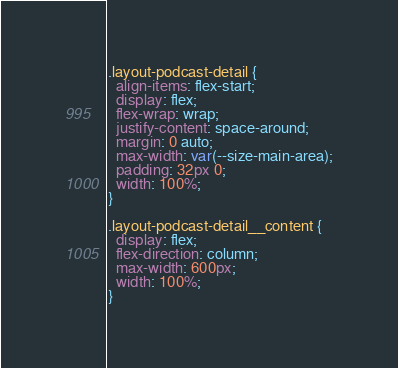<code> <loc_0><loc_0><loc_500><loc_500><_CSS_>.layout-podcast-detail {
  align-items: flex-start;
  display: flex;
  flex-wrap: wrap;
  justify-content: space-around;
  margin: 0 auto;
  max-width: var(--size-main-area);
  padding: 32px 0;
  width: 100%;
}

.layout-podcast-detail__content {
  display: flex;
  flex-direction: column;
  max-width: 600px;
  width: 100%;
}
</code> 